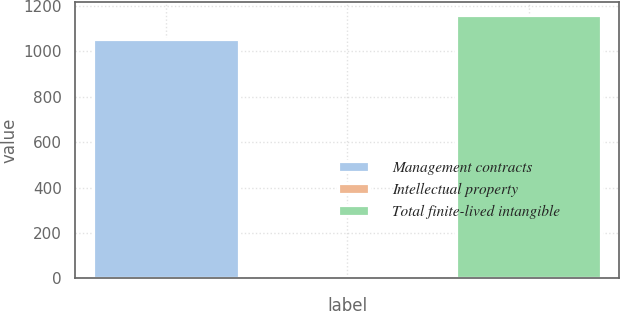Convert chart. <chart><loc_0><loc_0><loc_500><loc_500><bar_chart><fcel>Management contracts<fcel>Intellectual property<fcel>Total finite-lived intangible<nl><fcel>1054<fcel>3<fcel>1159.4<nl></chart> 